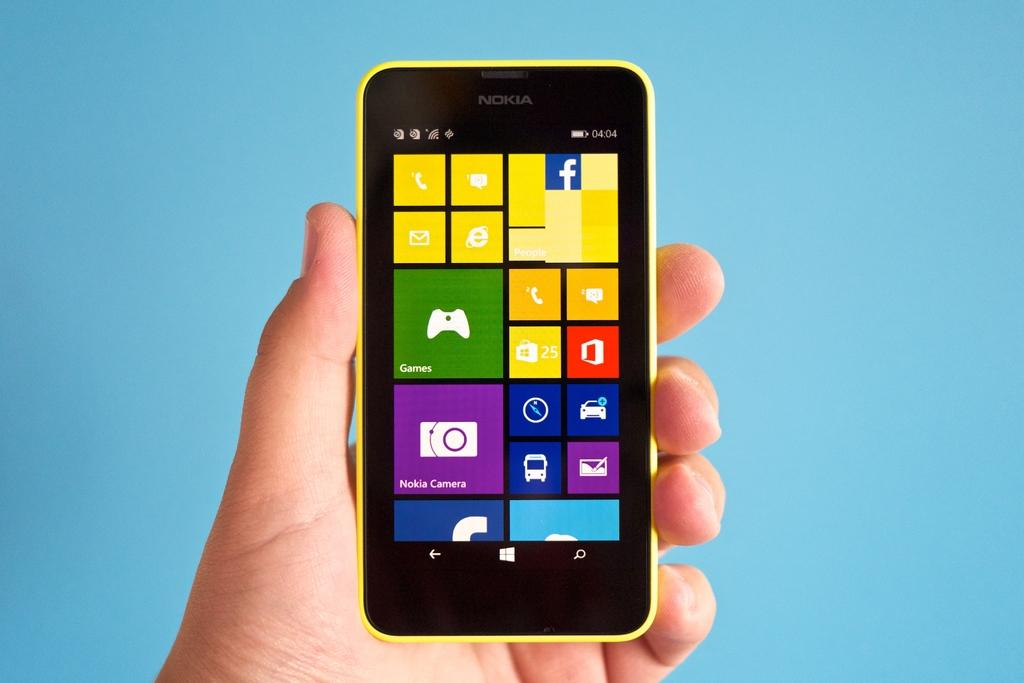<image>
Describe the image concisely. a person is holding a yellow nokia phone 